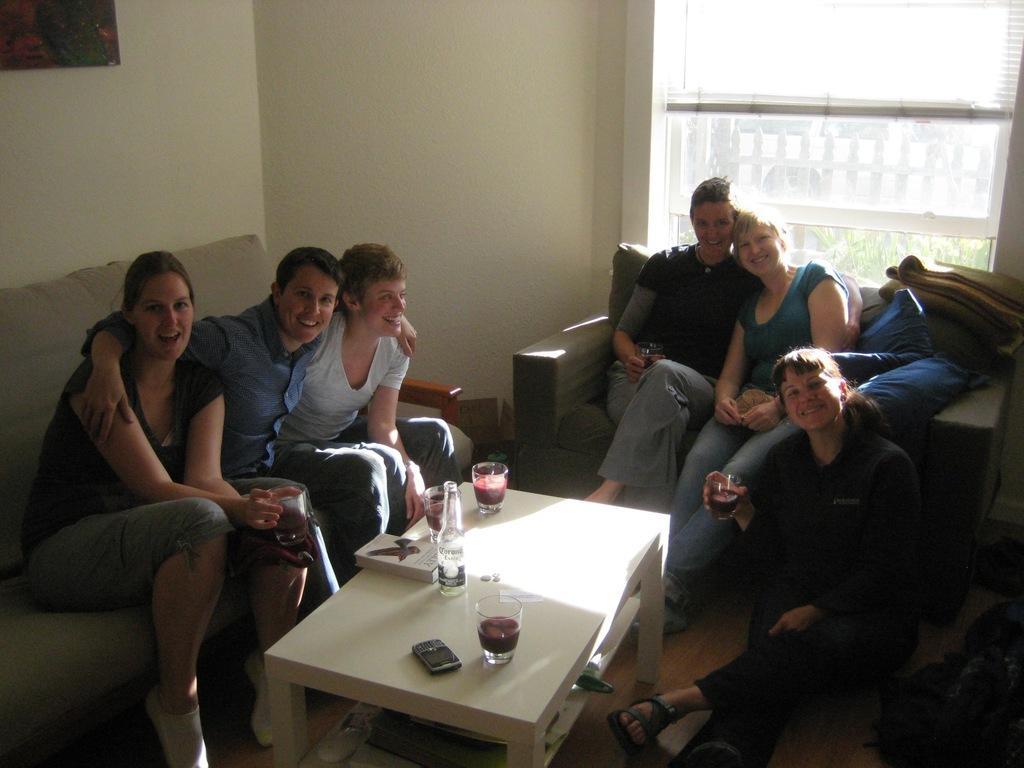Please provide a concise description of this image. The picture is taken inside a room. On the sofa there are few people sitting. On the ground a lady is sitting. She is holding a glass. On the table there are glasses, bottle, book and phone. in the background there is a window. 